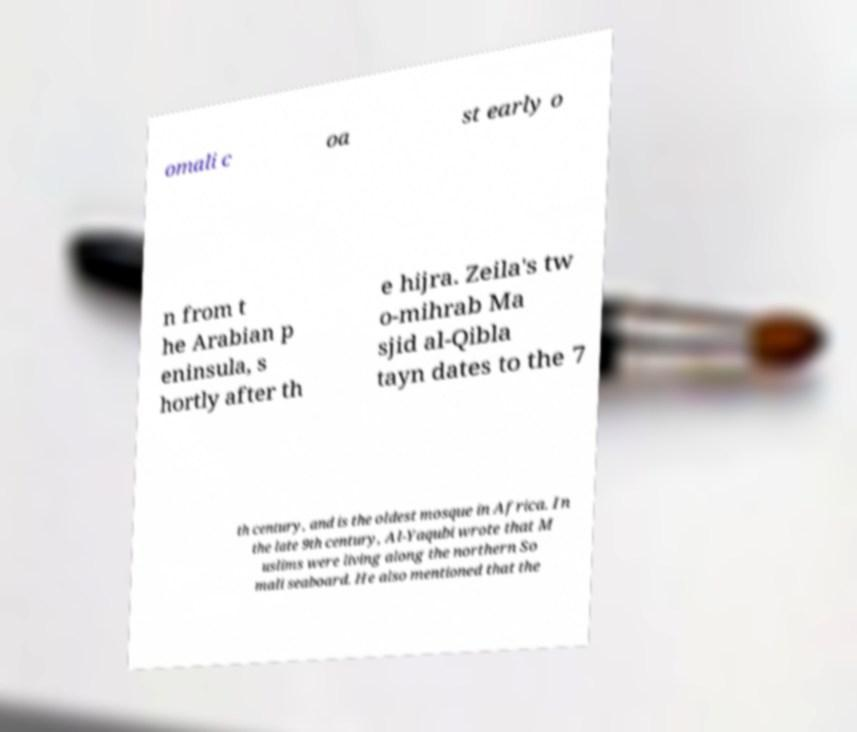Can you read and provide the text displayed in the image?This photo seems to have some interesting text. Can you extract and type it out for me? omali c oa st early o n from t he Arabian p eninsula, s hortly after th e hijra. Zeila's tw o-mihrab Ma sjid al-Qibla tayn dates to the 7 th century, and is the oldest mosque in Africa. In the late 9th century, Al-Yaqubi wrote that M uslims were living along the northern So mali seaboard. He also mentioned that the 